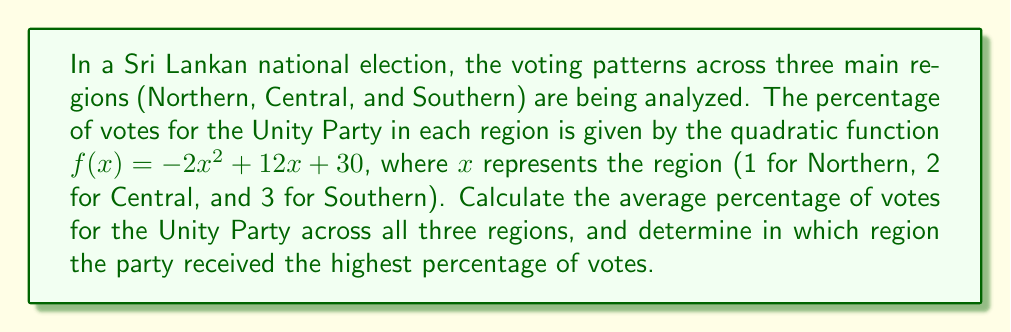What is the answer to this math problem? 1. First, let's calculate the percentage of votes for each region:

   Northern (x = 1): $f(1) = -2(1)^2 + 12(1) + 30 = -2 + 12 + 30 = 40\%$
   Central (x = 2): $f(2) = -2(2)^2 + 12(2) + 30 = -8 + 24 + 30 = 46\%$
   Southern (x = 3): $f(3) = -2(3)^2 + 12(3) + 30 = -18 + 36 + 30 = 48\%$

2. To find the average percentage, we sum the percentages and divide by 3:

   Average = $\frac{40\% + 46\% + 48\%}{3} = \frac{134\%}{3} = 44.67\%$

3. To determine which region had the highest percentage, we compare the values:

   Northern: 40%
   Central: 46%
   Southern: 48%

   The Southern region has the highest percentage at 48%.
Answer: Average: 44.67%; Highest: Southern region (48%) 